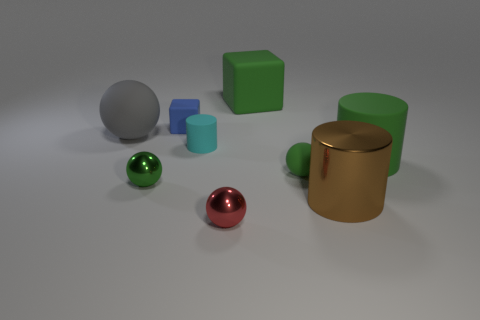Is there any other thing that has the same size as the blue cube?
Provide a short and direct response. Yes. What material is the large green thing in front of the green object that is behind the tiny matte cylinder?
Give a very brief answer. Rubber. Are there more blue rubber cubes that are right of the tiny green rubber thing than gray matte spheres in front of the tiny red ball?
Provide a short and direct response. No. What is the size of the cyan rubber thing?
Give a very brief answer. Small. There is a cylinder that is in front of the large green cylinder; is it the same color as the small rubber block?
Offer a very short reply. No. Are there any other things that have the same shape as the blue matte object?
Provide a short and direct response. Yes. Are there any cyan cylinders that are right of the big green object to the right of the big brown metallic object?
Keep it short and to the point. No. Are there fewer matte things on the left side of the tiny red shiny object than large things in front of the cyan object?
Offer a very short reply. No. How big is the cylinder that is in front of the green ball in front of the small matte thing to the right of the red ball?
Give a very brief answer. Large. There is a green sphere that is left of the cyan rubber cylinder; does it have the same size as the big rubber block?
Provide a short and direct response. No. 